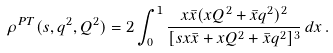Convert formula to latex. <formula><loc_0><loc_0><loc_500><loc_500>\rho ^ { P T } ( s , q ^ { 2 } , Q ^ { 2 } ) = 2 \int _ { 0 } ^ { 1 } \frac { x \bar { x } ( x Q ^ { 2 } + \bar { x } q ^ { 2 } ) ^ { 2 } } { [ s { x } \bar { x } + x Q ^ { 2 } + \bar { x } q ^ { 2 } ] ^ { 3 } } \, d x \, .</formula> 